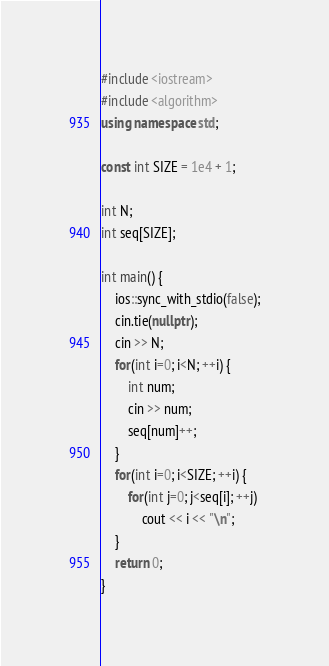<code> <loc_0><loc_0><loc_500><loc_500><_C++_>#include <iostream>
#include <algorithm>
using namespace std;

const int SIZE = 1e4 + 1;

int N;
int seq[SIZE];

int main() {
	ios::sync_with_stdio(false);
	cin.tie(nullptr);
	cin >> N;	
	for(int i=0; i<N; ++i) {
		int num;
		cin >> num;
		seq[num]++;
	}
	for(int i=0; i<SIZE; ++i) {
		for(int j=0; j<seq[i]; ++j)
			cout << i << "\n";
	}
	return 0;
}
</code> 